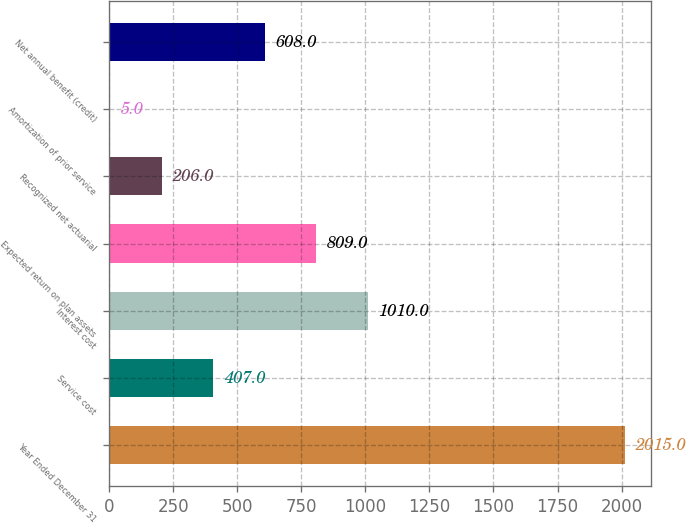Convert chart. <chart><loc_0><loc_0><loc_500><loc_500><bar_chart><fcel>Year Ended December 31<fcel>Service cost<fcel>Interest cost<fcel>Expected return on plan assets<fcel>Recognized net actuarial<fcel>Amortization of prior service<fcel>Net annual benefit (credit)<nl><fcel>2015<fcel>407<fcel>1010<fcel>809<fcel>206<fcel>5<fcel>608<nl></chart> 